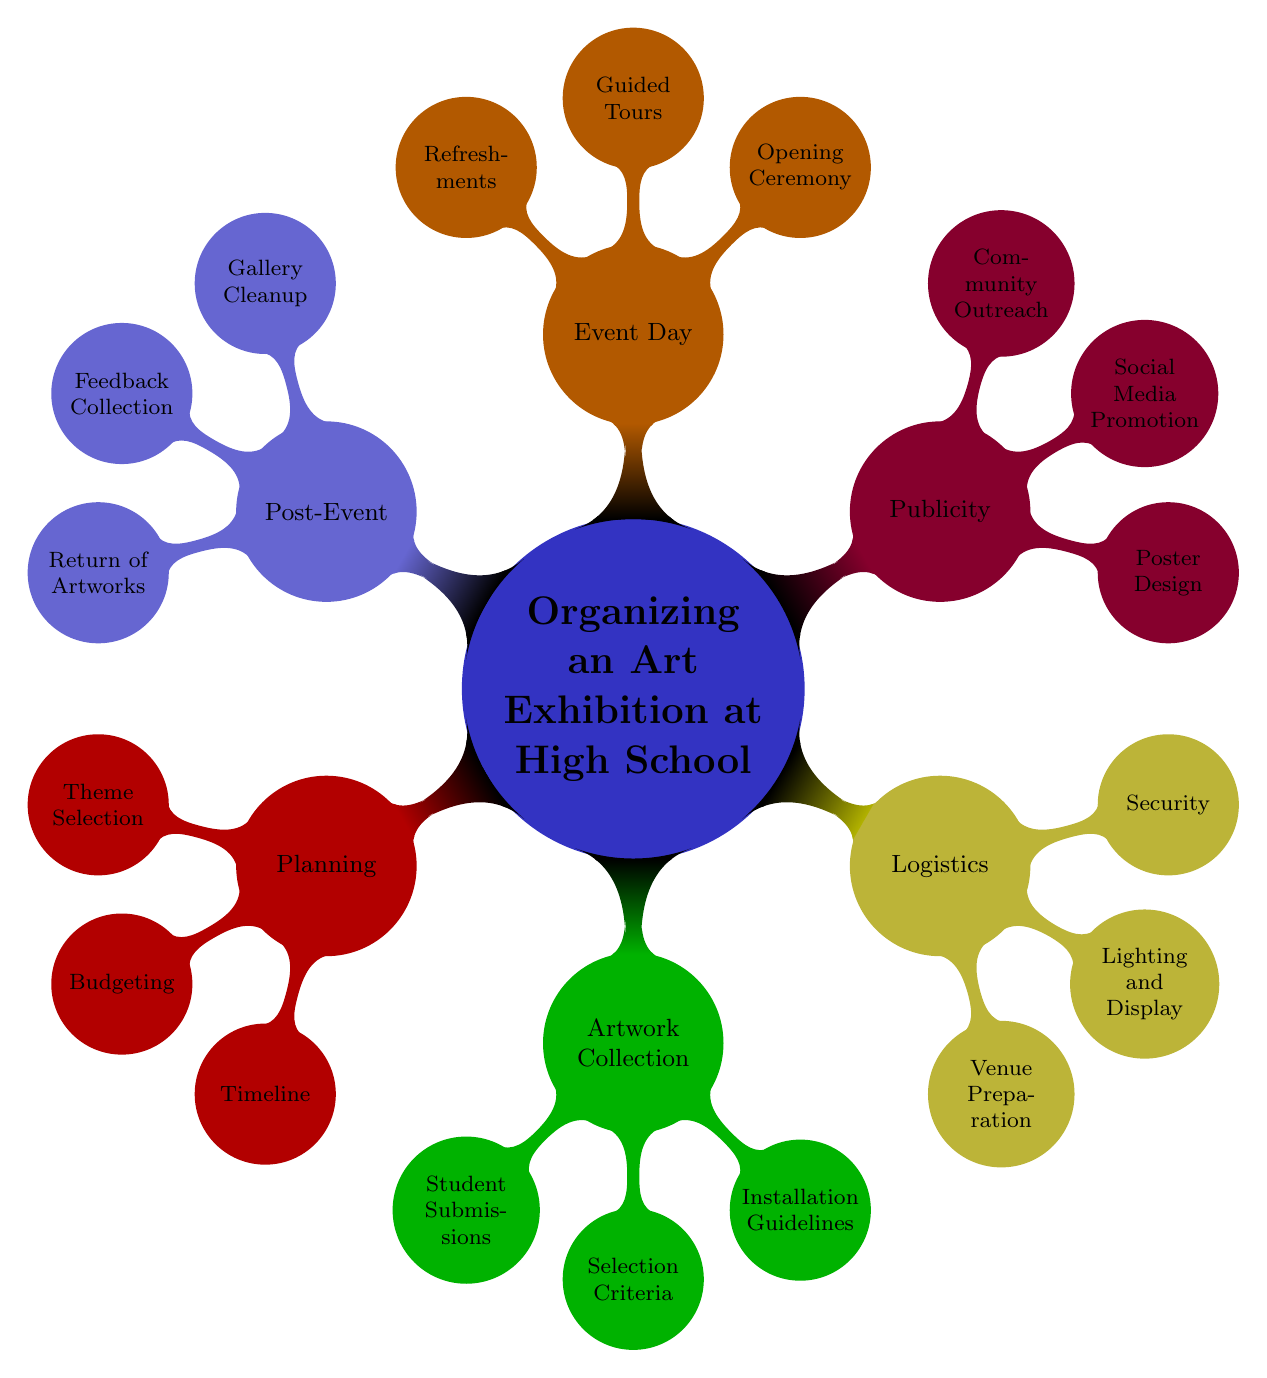What is the main topic of the mind map? The main topic is explicitly mentioned at the center of the diagram as "Organizing an Art Exhibition at High School."
Answer: Organizing an Art Exhibition at High School How many subtopics are represented in the diagram? The main topic branches off into six distinct subtopics: Planning, Artwork Collection, Logistics, Publicity, Event Day, and Post-Event. Counting these gives a total of six.
Answer: 6 What is one element listed under the Publicity subtopic? Looking at the Publicity subtopic, it has three elements listed: Poster Design, Social Media Promotion, and Community Outreach. Any one of these can be the answer, and "Poster Design" is used here.
Answer: Poster Design Which subtopic includes "Venue Preparation"? "Venue Preparation" is found under the Logistics subtopic as one of its elements. This can be seen in the relevant branch of the diagram.
Answer: Logistics What are the three elements under the Planning subtopic? The Planning subtopic lists three elements: Theme Selection, Budgeting, and Timeline. These elements are directly visible under the Planning branch in the diagram.
Answer: Theme Selection, Budgeting, Timeline Which subtopic comes directly after Artwork Collection in the mind map? Evaluating the structure of the mind map, "Logistics" is the subtopic that follows "Artwork Collection" in the branching order. This can be traced by moving along the branches from the main topic.
Answer: Logistics How many elements are listed under the Post-Event subtopic? The Post-Event subtopic includes three elements: Gallery Cleanup, Feedback Collection, and Return of Artworks. Counting these gives a total of three.
Answer: 3 What is the purpose of the Event Day subtopic? The Event Day subtopic contains elements directly related to the activities that occur on the day of the exhibition, including Opening Ceremony, Guided Tours, and Refreshments. Therefore, its purpose is to outline the day-of-exhibition activities.
Answer: Activities on the day of the exhibition What distinguishes a mind map from other diagram types? A mind map uses a central node to organize information hierarchically, with branches representing subtopics, which is a unique feature compared to linear or flowchart diagrams that might not incorporate such a networked, radial structure.
Answer: Central node with hierarchical structure 